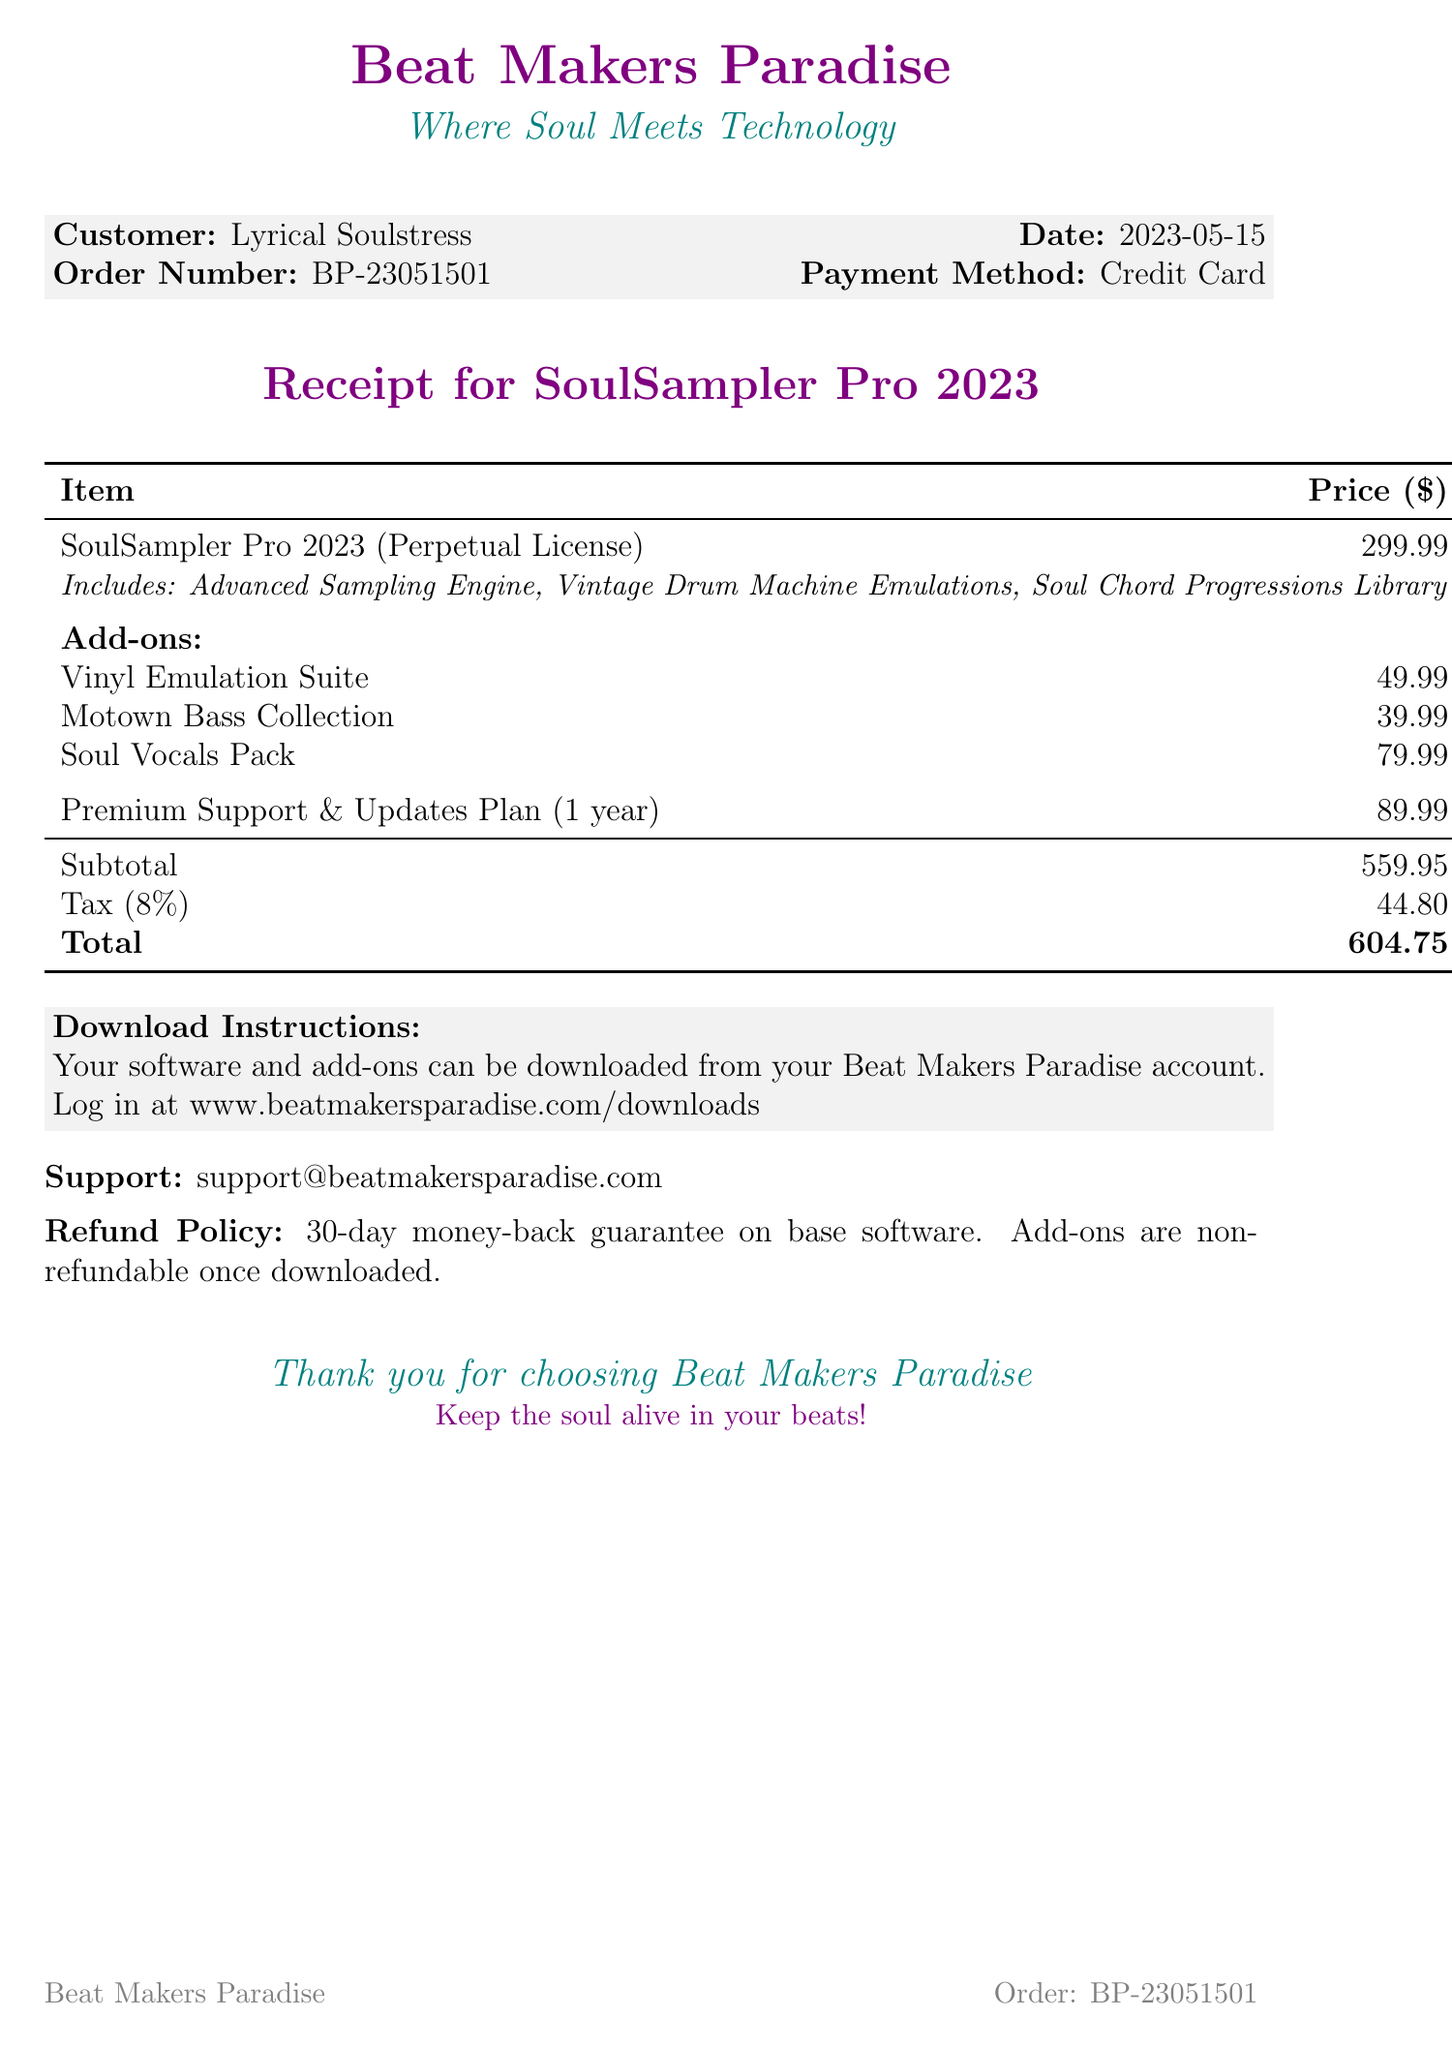What is the name of the software? The document explicitly states that the software is called "SoulSampler Pro 2023."
Answer: SoulSampler Pro 2023 Who is the customer? The receipt lists "Lyrical Soulstress" as the customer name.
Answer: Lyrical Soulstress What is the purchase date? The receipt mentions the purchase date as "2023-05-15."
Answer: 2023-05-15 What is the total amount due? The total amount, including tax, is clearly listed as $604.75.
Answer: 604.75 What feature aids in sample quality? The "Advanced Sampling Engine" is highlighted for its quality in time-stretching and pitch-shifting for soul samples.
Answer: Advanced Sampling Engine How much does the "Soul Vocals Pack" cost? The cost of the "Soul Vocals Pack" is specified to be $79.99.
Answer: 79.99 What is included in the software's base price? The document lists several features included with the software, specifically naming the "Advanced Sampling Engine," "Vintage Drum Machine Emulations," and "Soul Chord Progressions Library."
Answer: Advanced Sampling Engine, Vintage Drum Machine Emulations, Soul Chord Progressions Library What is the duration of the support plan? The document states that the Premium Support & Updates Plan is for "1 year."
Answer: 1 year What is the refund policy for add-ons? The receipt specifies that "Add-ons are non-refundable once downloaded."
Answer: Non-refundable once downloaded 